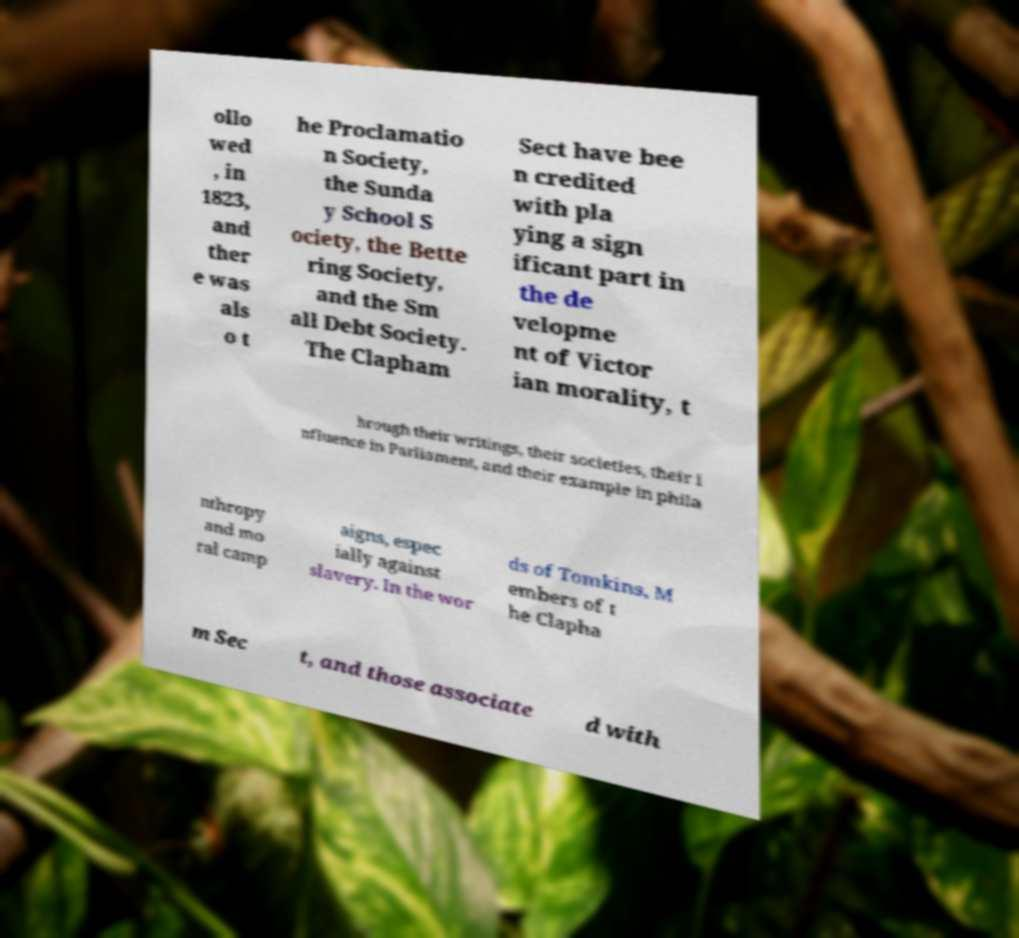What messages or text are displayed in this image? I need them in a readable, typed format. ollo wed , in 1823, and ther e was als o t he Proclamatio n Society, the Sunda y School S ociety, the Bette ring Society, and the Sm all Debt Society. The Clapham Sect have bee n credited with pla ying a sign ificant part in the de velopme nt of Victor ian morality, t hrough their writings, their societies, their i nfluence in Parliament, and their example in phila nthropy and mo ral camp aigns, espec ially against slavery. In the wor ds of Tomkins, M embers of t he Clapha m Sec t, and those associate d with 